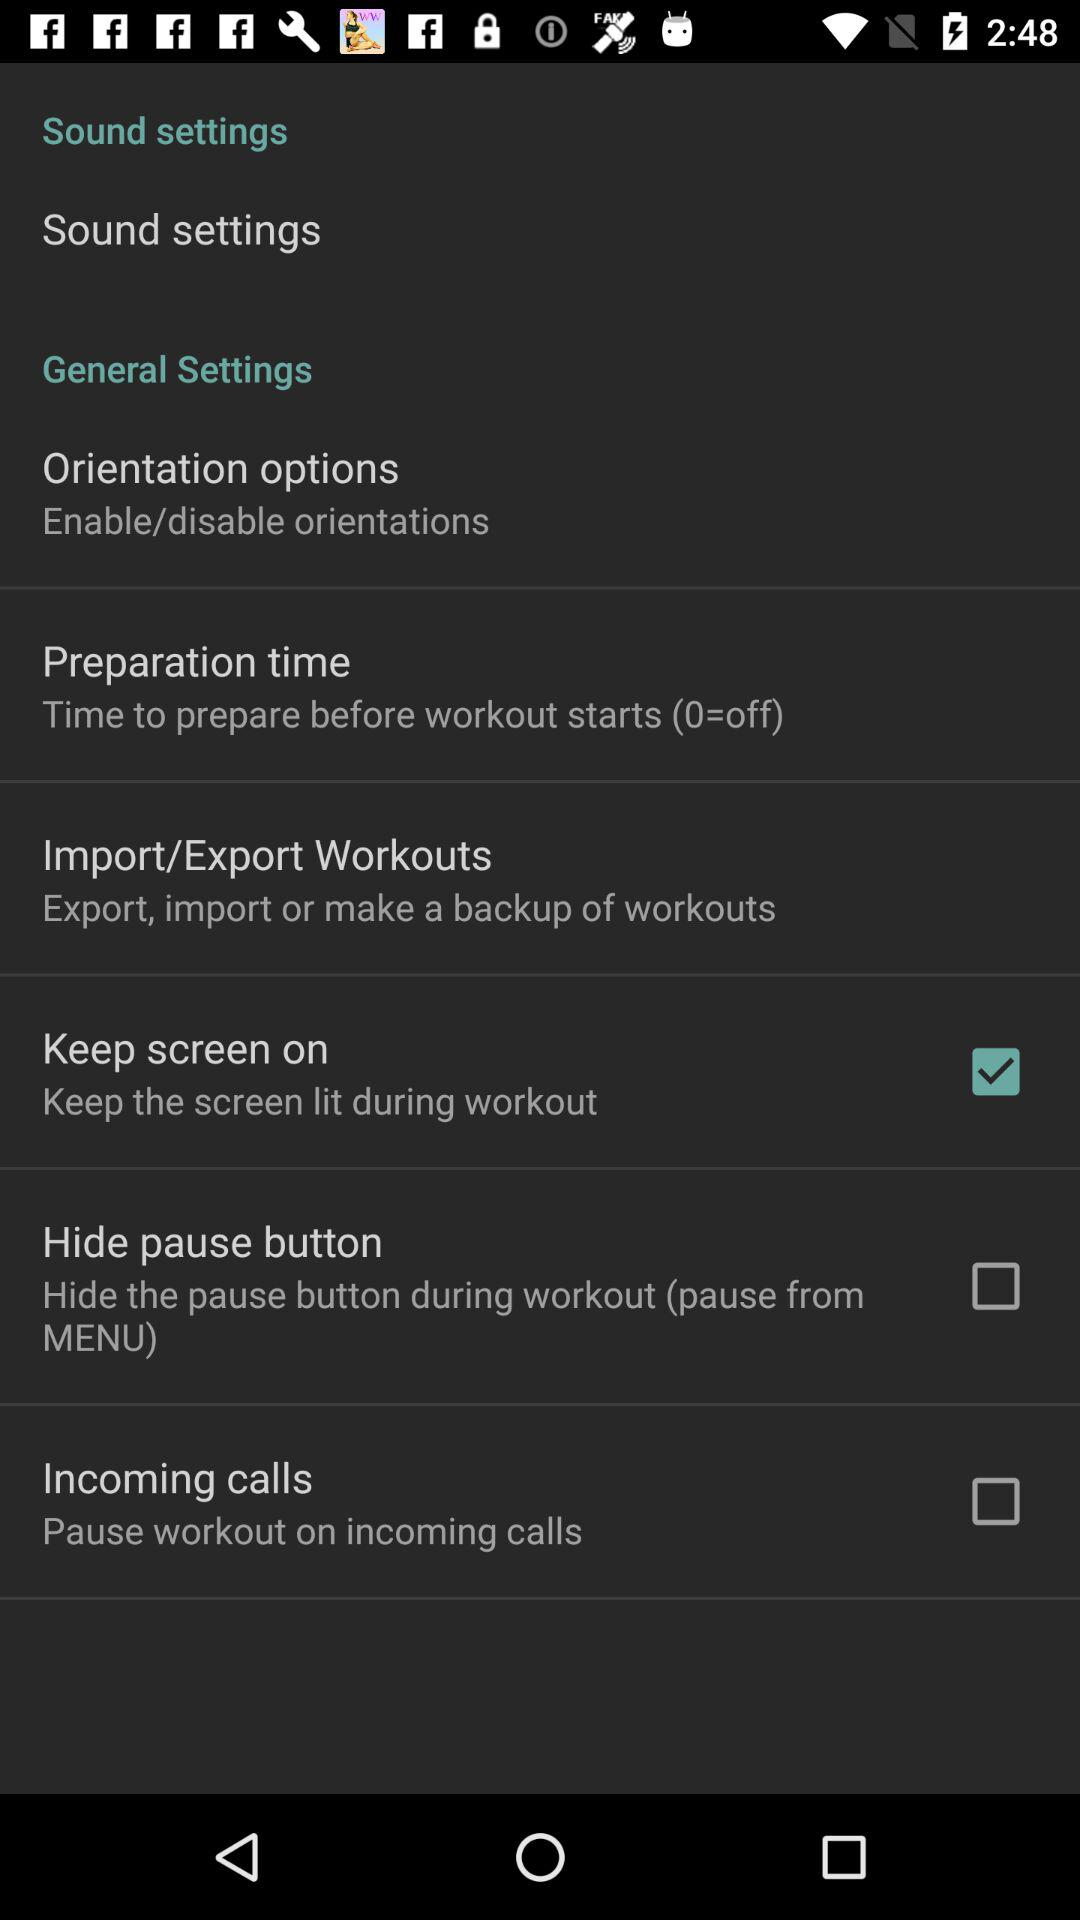What is the status of the high pause button? The status is "off". 